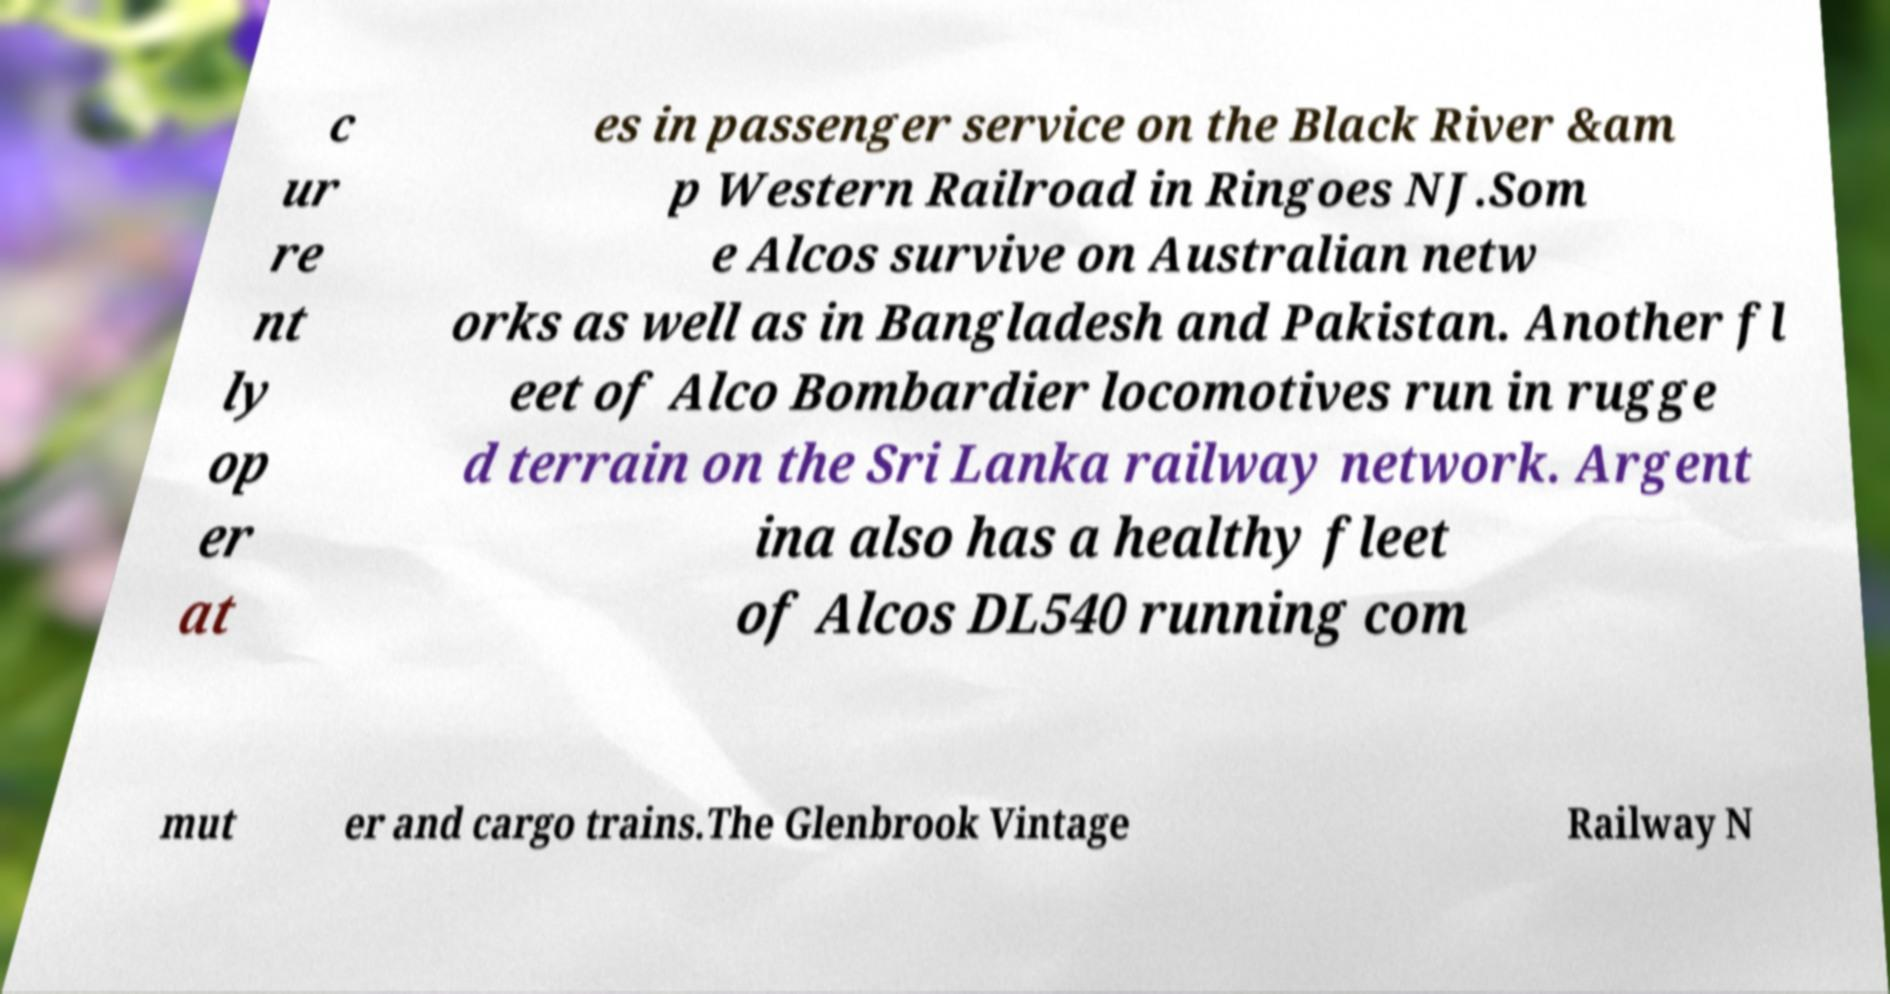I need the written content from this picture converted into text. Can you do that? c ur re nt ly op er at es in passenger service on the Black River &am p Western Railroad in Ringoes NJ.Som e Alcos survive on Australian netw orks as well as in Bangladesh and Pakistan. Another fl eet of Alco Bombardier locomotives run in rugge d terrain on the Sri Lanka railway network. Argent ina also has a healthy fleet of Alcos DL540 running com mut er and cargo trains.The Glenbrook Vintage Railway N 